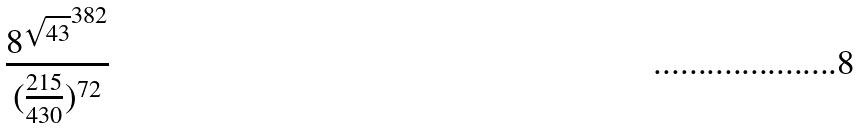Convert formula to latex. <formula><loc_0><loc_0><loc_500><loc_500>\frac { { 8 ^ { \sqrt { 4 3 } } } ^ { 3 8 2 } } { ( \frac { 2 1 5 } { 4 3 0 } ) ^ { 7 2 } }</formula> 